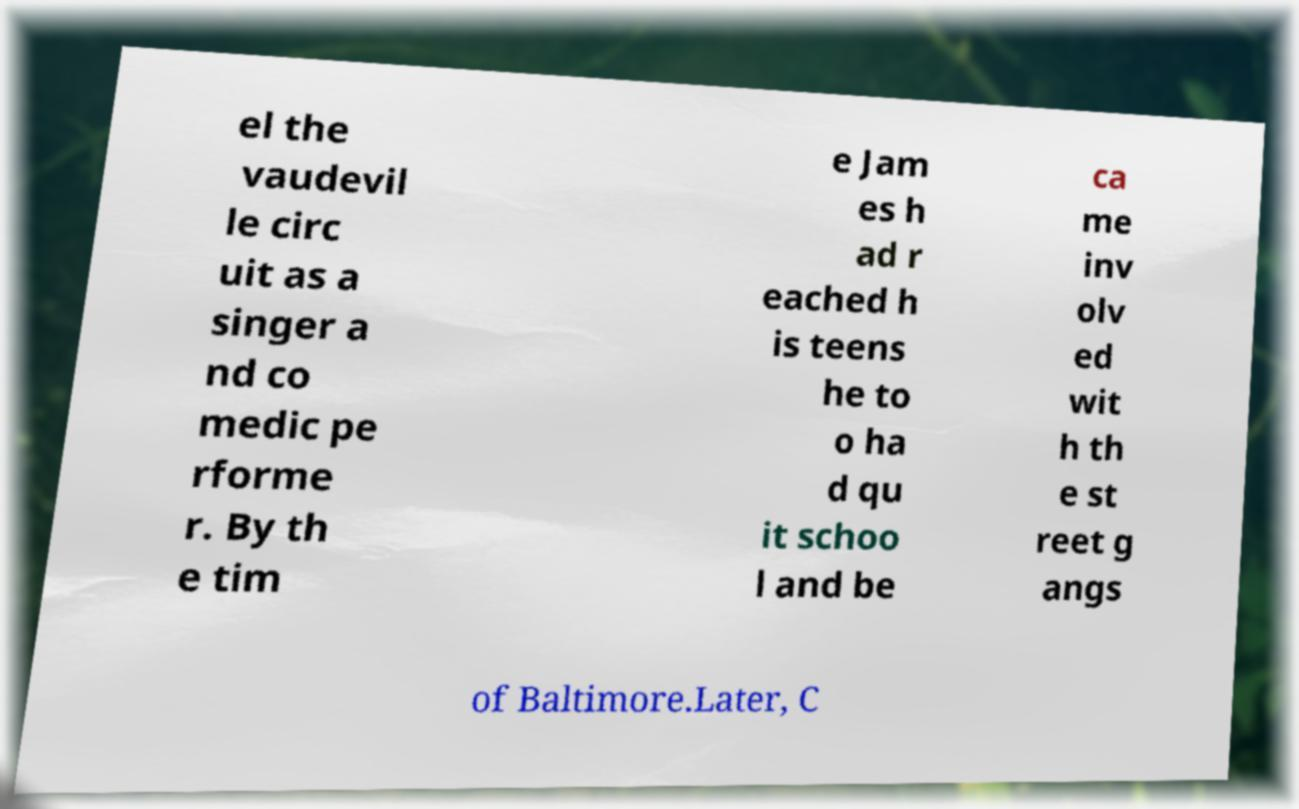Can you accurately transcribe the text from the provided image for me? el the vaudevil le circ uit as a singer a nd co medic pe rforme r. By th e tim e Jam es h ad r eached h is teens he to o ha d qu it schoo l and be ca me inv olv ed wit h th e st reet g angs of Baltimore.Later, C 